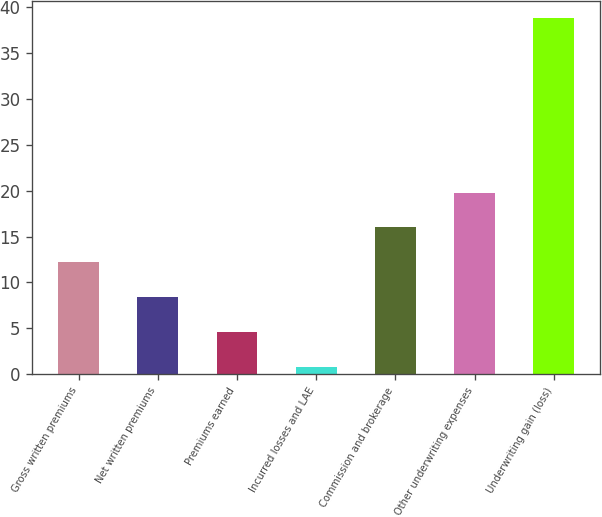<chart> <loc_0><loc_0><loc_500><loc_500><bar_chart><fcel>Gross written premiums<fcel>Net written premiums<fcel>Premiums earned<fcel>Incurred losses and LAE<fcel>Commission and brokerage<fcel>Other underwriting expenses<fcel>Underwriting gain (loss)<nl><fcel>12.2<fcel>8.4<fcel>4.6<fcel>0.8<fcel>16<fcel>19.8<fcel>38.8<nl></chart> 